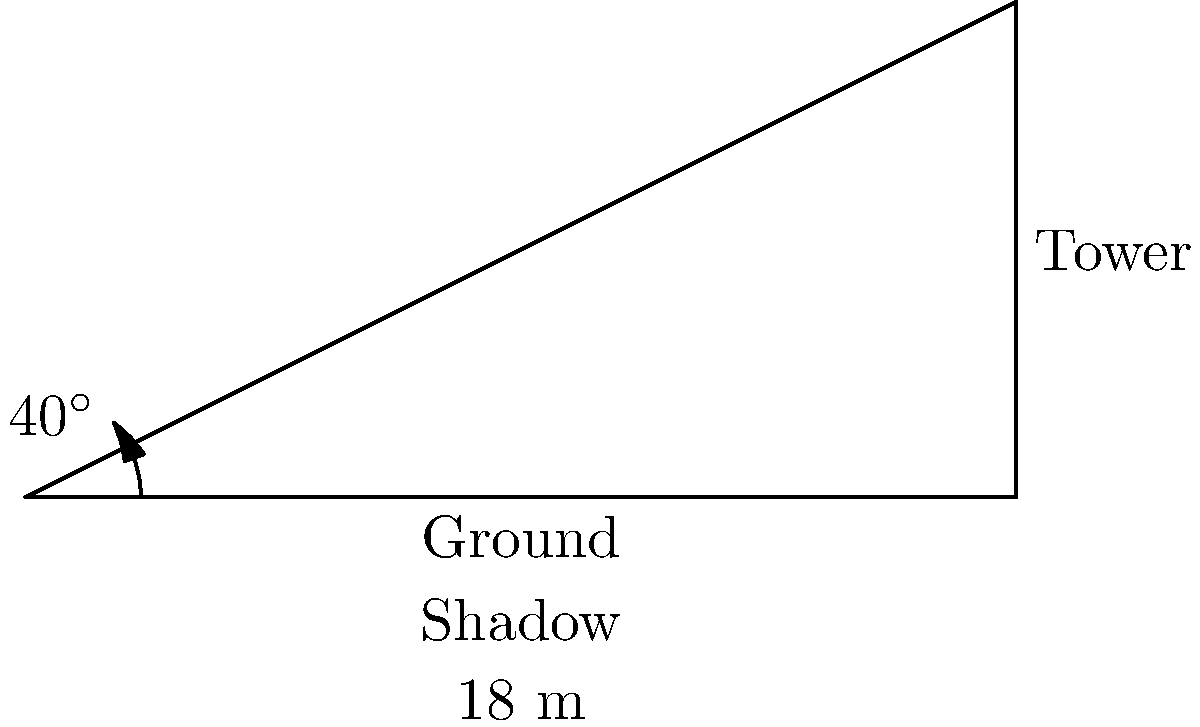At the Mount Polley mine, you notice a tall equipment tower casting a shadow on the ground. The shadow is 18 meters long, and the angle of elevation of the sun is 40°. Using this information, calculate the height of the mining equipment tower. To solve this problem, we'll use trigonometry, specifically the tangent function. Here's the step-by-step solution:

1) In a right triangle, tangent of an angle is the ratio of the opposite side to the adjacent side.

2) In this case:
   - The angle is 40° (angle of elevation of the sun)
   - The adjacent side is 18 m (length of the shadow)
   - The opposite side is the height of the tower (what we're solving for)

3) Let's call the height of the tower $h$. We can write the equation:

   $\tan(40°) = \frac{h}{18}$

4) To solve for $h$, multiply both sides by 18:

   $18 \cdot \tan(40°) = h$

5) Now, we can calculate:
   $h = 18 \cdot \tan(40°)$

6) Using a calculator (or trigonometric tables):
   $\tan(40°) \approx 0.8391$

7) Therefore:
   $h = 18 \cdot 0.8391 \approx 15.1038$ meters

8) Rounding to the nearest tenth:
   $h \approx 15.1$ meters
Answer: 15.1 meters 